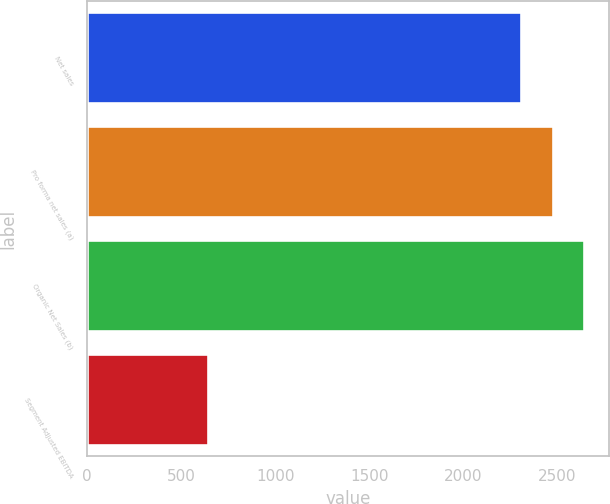Convert chart. <chart><loc_0><loc_0><loc_500><loc_500><bar_chart><fcel>Net sales<fcel>Pro forma net sales (a)<fcel>Organic Net Sales (b)<fcel>Segment Adjusted EBITDA<nl><fcel>2309<fcel>2475.7<fcel>2642.4<fcel>642<nl></chart> 